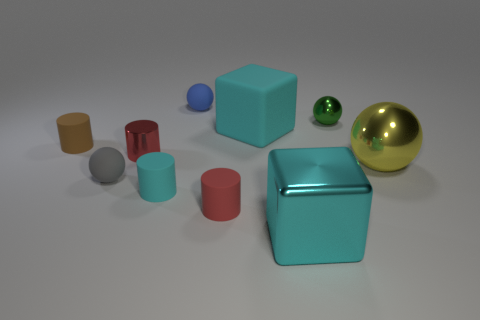Do the tiny gray object and the big thing behind the large yellow sphere have the same material?
Your answer should be very brief. Yes. What material is the tiny brown thing?
Offer a very short reply. Rubber. What material is the big cyan thing in front of the tiny red thing that is on the right side of the object behind the green shiny sphere?
Provide a short and direct response. Metal. Does the large matte block have the same color as the metallic sphere behind the big yellow thing?
Keep it short and to the point. No. Are there any other things that are the same shape as the tiny gray rubber object?
Your answer should be compact. Yes. What color is the block that is in front of the shiny ball in front of the large cyan matte cube?
Provide a short and direct response. Cyan. How many large gray matte cubes are there?
Your answer should be very brief. 0. How many rubber objects are tiny yellow objects or tiny green things?
Your answer should be compact. 0. What number of big metal cylinders have the same color as the large metal block?
Offer a terse response. 0. What material is the tiny sphere behind the metal sphere that is on the left side of the yellow thing?
Provide a succinct answer. Rubber. 